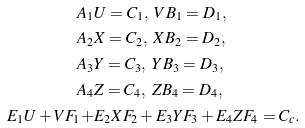<formula> <loc_0><loc_0><loc_500><loc_500>A _ { 1 } & U = C _ { 1 } , \ V B _ { 1 } = D _ { 1 } , \\ A _ { 2 } & X = C _ { 2 } , \ X B _ { 2 } = D _ { 2 } , \\ A _ { 3 } & Y = C _ { 3 } , \ Y B _ { 3 } = D _ { 3 } , \\ A _ { 4 } & Z = C _ { 4 } , \ Z B _ { 4 } = D _ { 4 } , \\ E _ { 1 } U + V F _ { 1 } + & E _ { 2 } X F _ { 2 } + E _ { 3 } Y F _ { 3 } + E _ { 4 } Z F _ { 4 } = C _ { c } .</formula> 